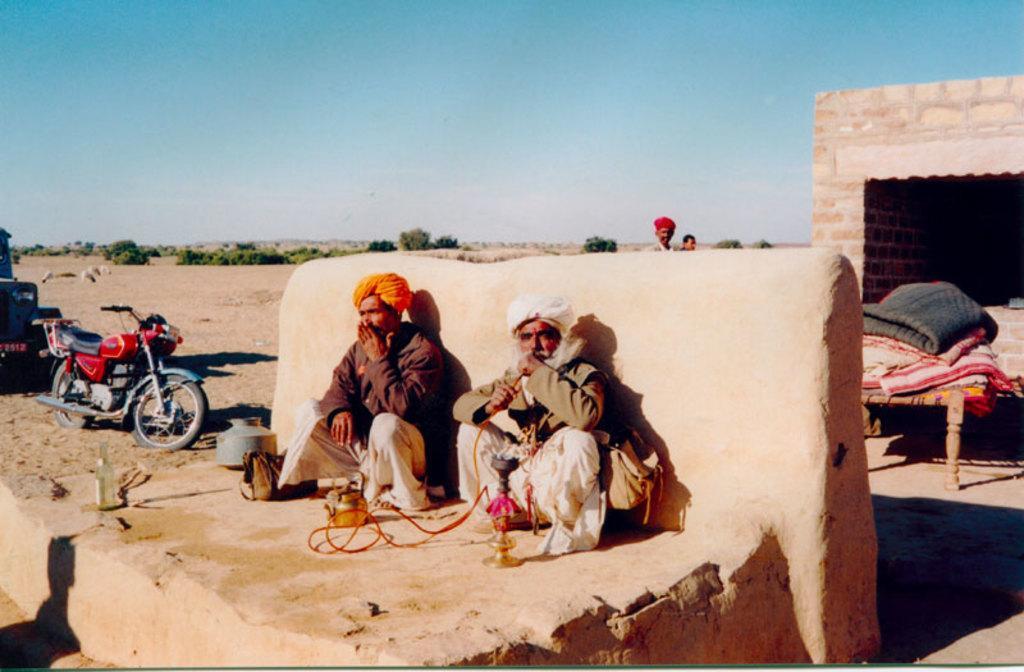Can you describe this image briefly? In this picture there are people, among them there are two men sitting like squat position and this man holding a pipe and carrying a bag. We can see bag, bottle, kettle and objects. We can see vehicles, bed sheets, cot and sand. In the background of the image we can see wall, trees and sky. 